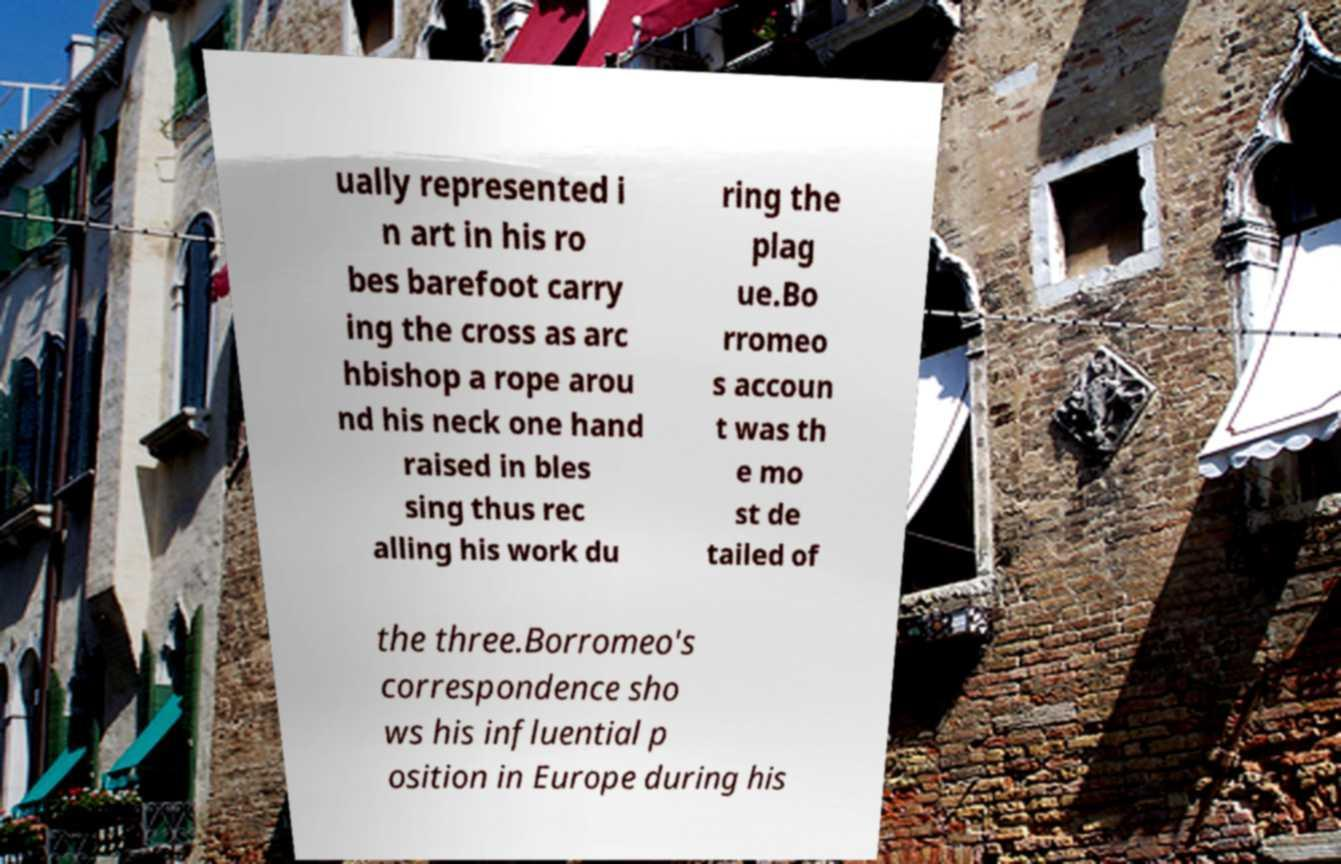Can you accurately transcribe the text from the provided image for me? ually represented i n art in his ro bes barefoot carry ing the cross as arc hbishop a rope arou nd his neck one hand raised in bles sing thus rec alling his work du ring the plag ue.Bo rromeo s accoun t was th e mo st de tailed of the three.Borromeo's correspondence sho ws his influential p osition in Europe during his 